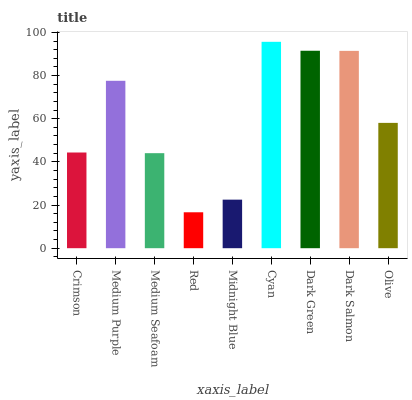Is Medium Purple the minimum?
Answer yes or no. No. Is Medium Purple the maximum?
Answer yes or no. No. Is Medium Purple greater than Crimson?
Answer yes or no. Yes. Is Crimson less than Medium Purple?
Answer yes or no. Yes. Is Crimson greater than Medium Purple?
Answer yes or no. No. Is Medium Purple less than Crimson?
Answer yes or no. No. Is Olive the high median?
Answer yes or no. Yes. Is Olive the low median?
Answer yes or no. Yes. Is Medium Seafoam the high median?
Answer yes or no. No. Is Medium Seafoam the low median?
Answer yes or no. No. 